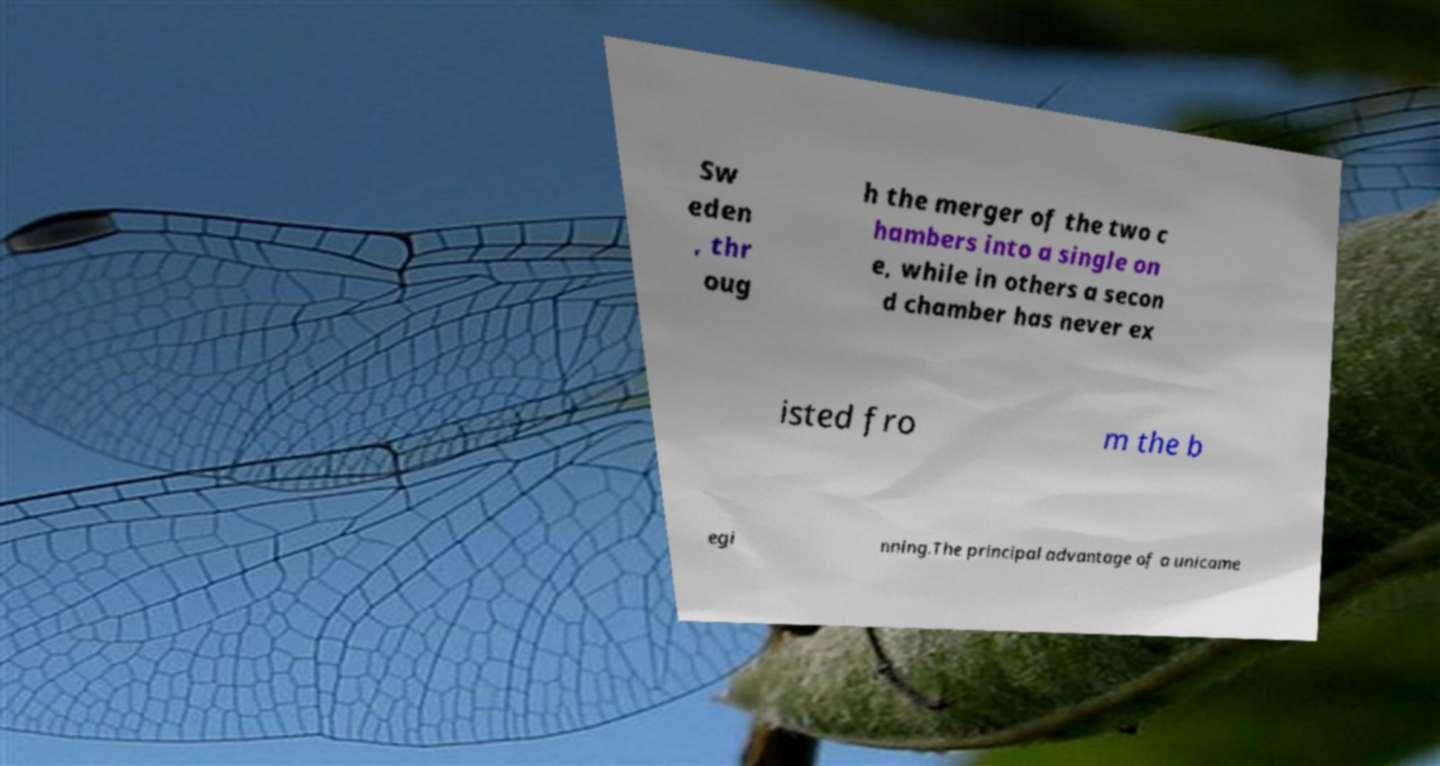There's text embedded in this image that I need extracted. Can you transcribe it verbatim? Sw eden , thr oug h the merger of the two c hambers into a single on e, while in others a secon d chamber has never ex isted fro m the b egi nning.The principal advantage of a unicame 